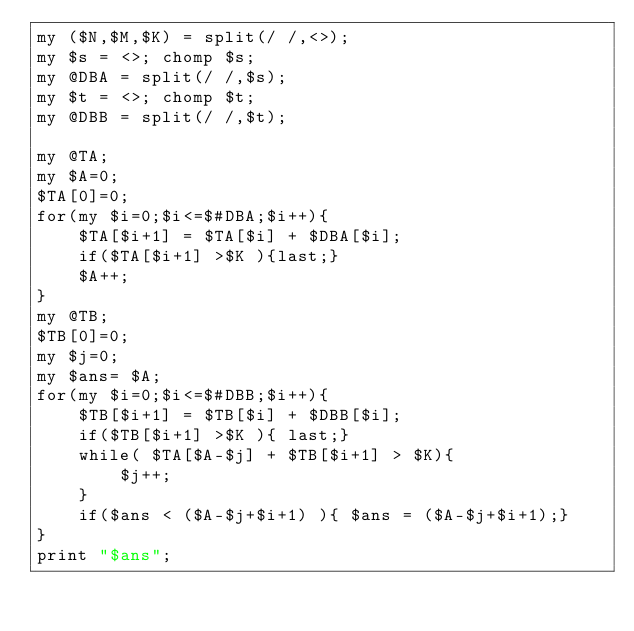<code> <loc_0><loc_0><loc_500><loc_500><_Perl_>my ($N,$M,$K) = split(/ /,<>);
my $s = <>; chomp $s;
my @DBA = split(/ /,$s);
my $t = <>; chomp $t;
my @DBB = split(/ /,$t);

my @TA;
my $A=0;
$TA[0]=0;
for(my $i=0;$i<=$#DBA;$i++){
    $TA[$i+1] = $TA[$i] + $DBA[$i];
    if($TA[$i+1] >$K ){last;}
    $A++;
}
my @TB;
$TB[0]=0;
my $j=0;
my $ans= $A;
for(my $i=0;$i<=$#DBB;$i++){
    $TB[$i+1] = $TB[$i] + $DBB[$i];
    if($TB[$i+1] >$K ){ last;}
    while( $TA[$A-$j] + $TB[$i+1] > $K){
        $j++;
    }
    if($ans < ($A-$j+$i+1) ){ $ans = ($A-$j+$i+1);}
}
print "$ans";</code> 